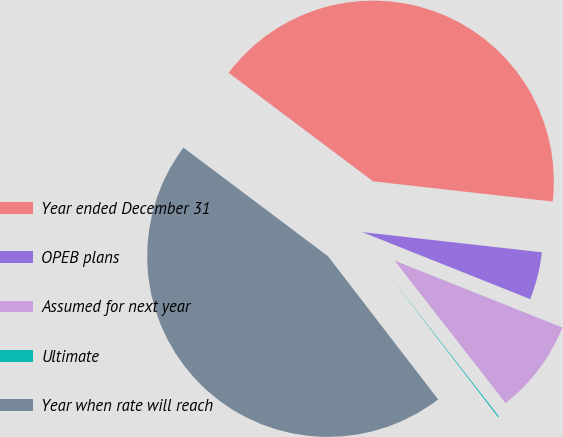Convert chart. <chart><loc_0><loc_0><loc_500><loc_500><pie_chart><fcel>Year ended December 31<fcel>OPEB plans<fcel>Assumed for next year<fcel>Ultimate<fcel>Year when rate will reach<nl><fcel>41.53%<fcel>4.26%<fcel>8.42%<fcel>0.1%<fcel>45.69%<nl></chart> 